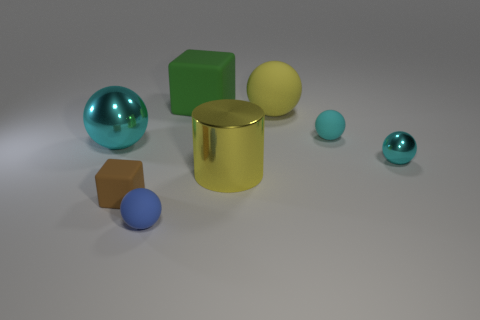Are there fewer cyan rubber objects that are on the left side of the blue object than matte blocks that are in front of the big metallic sphere?
Offer a very short reply. Yes. The tiny cyan rubber object has what shape?
Your response must be concise. Sphere. There is a large sphere that is left of the big matte cube; what material is it?
Your answer should be very brief. Metal. There is a shiny sphere on the right side of the rubber cube in front of the large object that is to the right of the big cylinder; what size is it?
Offer a very short reply. Small. Does the object that is in front of the brown matte block have the same material as the big object behind the big matte ball?
Provide a succinct answer. Yes. What number of other things are there of the same color as the large cylinder?
Offer a terse response. 1. What number of objects are big balls on the left side of the big yellow matte ball or matte balls that are behind the large shiny sphere?
Provide a succinct answer. 3. What is the size of the ball that is on the left side of the rubber block in front of the large green matte object?
Provide a succinct answer. Large. What size is the blue matte object?
Offer a terse response. Small. There is a big metal thing that is on the right side of the tiny blue rubber object; is it the same color as the big sphere behind the large cyan sphere?
Offer a terse response. Yes. 